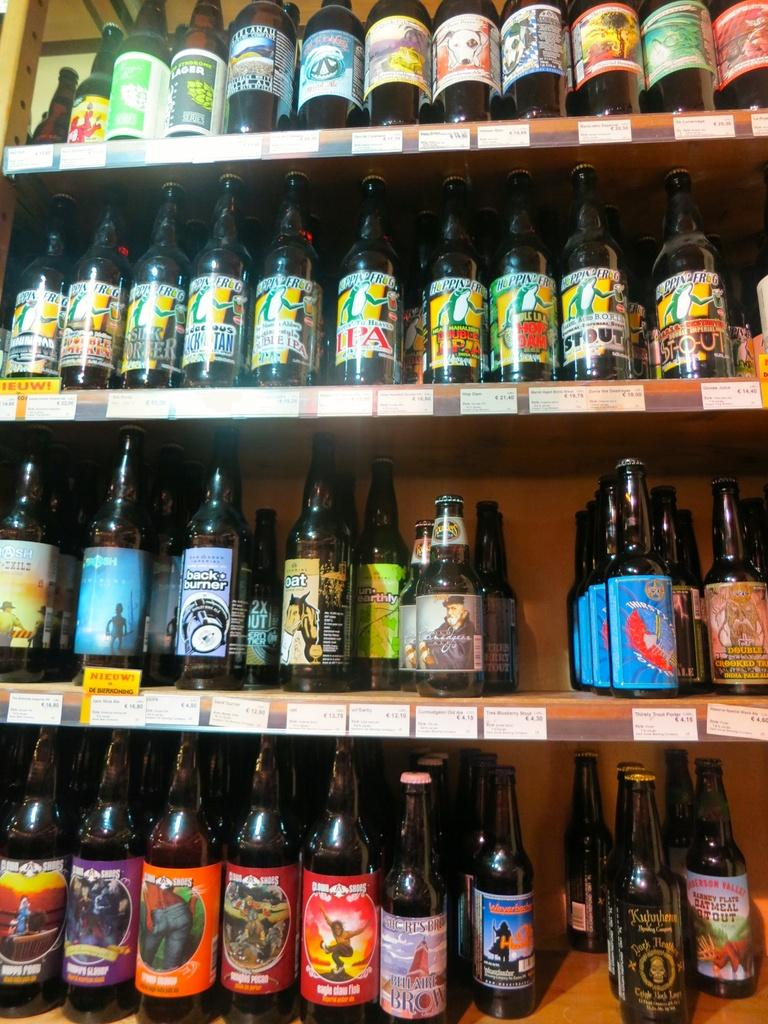What objects are in the image? There are bottles in a rack in the image. How are the bottles arranged in the image? The bottles are arranged in a rack in the image. Can you describe the bottles in the image? The bottles are in a rack, but their specific characteristics are not mentioned in the provided facts. What type of corn is being stored in the bottles in the image? There is no corn present in the image; it features bottles in a rack. How many cakes are visible on top of the bottles in the image? There are no cakes present in the image; it features bottles in a rack. 